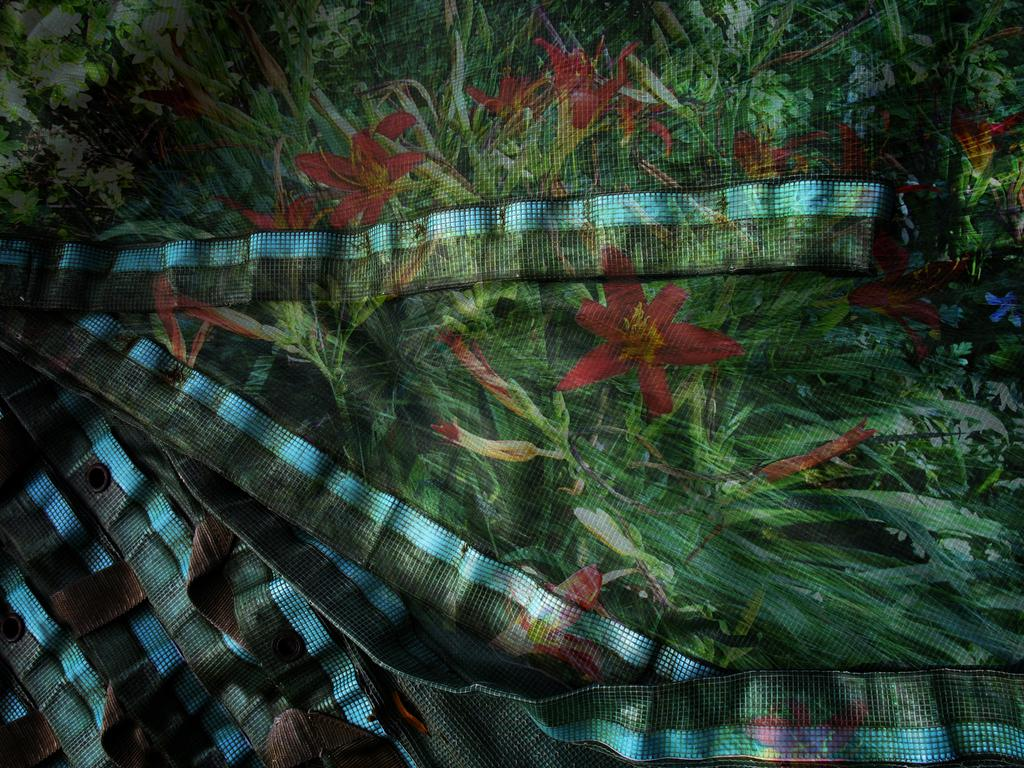What is the main object in the image? There is a cloth or sheet in the image. What colors are present on the cloth or sheet? The cloth or sheet has a white and green color. What design can be seen on the cloth or sheet? The sheet has plants and flowers painted on it. What station does the actor prefer to use when traveling in the image? There is no actor or station present in the image; it features a cloth or sheet with a white and green color and plants and flowers painted on it. 